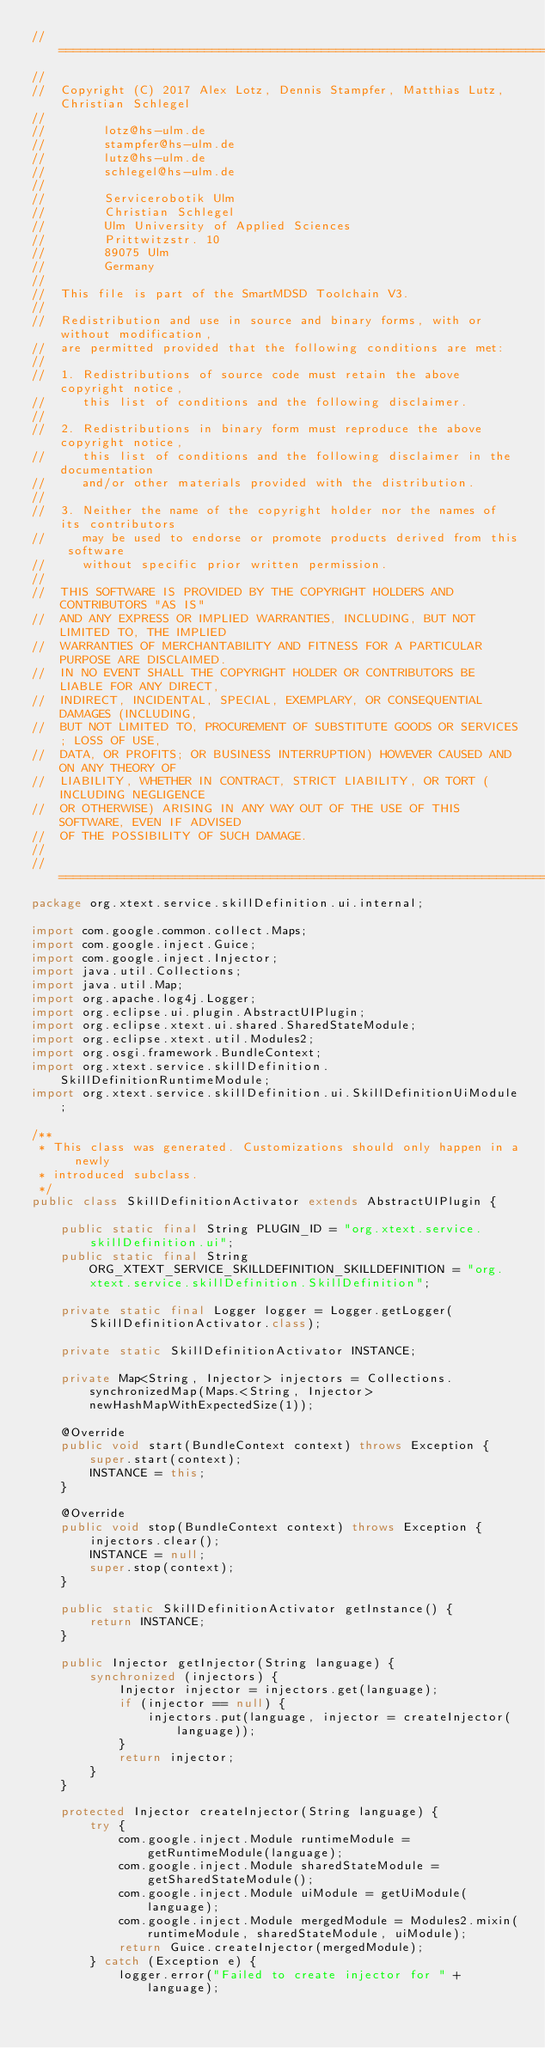<code> <loc_0><loc_0><loc_500><loc_500><_Java_>//===================================================================================
//
//  Copyright (C) 2017 Alex Lotz, Dennis Stampfer, Matthias Lutz, Christian Schlegel
//
//        lotz@hs-ulm.de
//        stampfer@hs-ulm.de
//        lutz@hs-ulm.de
//        schlegel@hs-ulm.de
//
//        Servicerobotik Ulm
//        Christian Schlegel
//        Ulm University of Applied Sciences
//        Prittwitzstr. 10
//        89075 Ulm
//        Germany
//
//  This file is part of the SmartMDSD Toolchain V3. 
//
//  Redistribution and use in source and binary forms, with or without modification, 
//  are permitted provided that the following conditions are met:
//  
//  1. Redistributions of source code must retain the above copyright notice, 
//     this list of conditions and the following disclaimer.
//  
//  2. Redistributions in binary form must reproduce the above copyright notice, 
//     this list of conditions and the following disclaimer in the documentation 
//     and/or other materials provided with the distribution.
//  
//  3. Neither the name of the copyright holder nor the names of its contributors 
//     may be used to endorse or promote products derived from this software 
//     without specific prior written permission.
//  
//  THIS SOFTWARE IS PROVIDED BY THE COPYRIGHT HOLDERS AND CONTRIBUTORS "AS IS" 
//  AND ANY EXPRESS OR IMPLIED WARRANTIES, INCLUDING, BUT NOT LIMITED TO, THE IMPLIED 
//  WARRANTIES OF MERCHANTABILITY AND FITNESS FOR A PARTICULAR PURPOSE ARE DISCLAIMED. 
//  IN NO EVENT SHALL THE COPYRIGHT HOLDER OR CONTRIBUTORS BE LIABLE FOR ANY DIRECT, 
//  INDIRECT, INCIDENTAL, SPECIAL, EXEMPLARY, OR CONSEQUENTIAL DAMAGES (INCLUDING, 
//  BUT NOT LIMITED TO, PROCUREMENT OF SUBSTITUTE GOODS OR SERVICES; LOSS OF USE, 
//  DATA, OR PROFITS; OR BUSINESS INTERRUPTION) HOWEVER CAUSED AND ON ANY THEORY OF 
//  LIABILITY, WHETHER IN CONTRACT, STRICT LIABILITY, OR TORT (INCLUDING NEGLIGENCE 
//  OR OTHERWISE) ARISING IN ANY WAY OUT OF THE USE OF THIS SOFTWARE, EVEN IF ADVISED 
//  OF THE POSSIBILITY OF SUCH DAMAGE.
//
//===================================================================================
package org.xtext.service.skillDefinition.ui.internal;

import com.google.common.collect.Maps;
import com.google.inject.Guice;
import com.google.inject.Injector;
import java.util.Collections;
import java.util.Map;
import org.apache.log4j.Logger;
import org.eclipse.ui.plugin.AbstractUIPlugin;
import org.eclipse.xtext.ui.shared.SharedStateModule;
import org.eclipse.xtext.util.Modules2;
import org.osgi.framework.BundleContext;
import org.xtext.service.skillDefinition.SkillDefinitionRuntimeModule;
import org.xtext.service.skillDefinition.ui.SkillDefinitionUiModule;

/**
 * This class was generated. Customizations should only happen in a newly
 * introduced subclass. 
 */
public class SkillDefinitionActivator extends AbstractUIPlugin {

	public static final String PLUGIN_ID = "org.xtext.service.skillDefinition.ui";
	public static final String ORG_XTEXT_SERVICE_SKILLDEFINITION_SKILLDEFINITION = "org.xtext.service.skillDefinition.SkillDefinition";
	
	private static final Logger logger = Logger.getLogger(SkillDefinitionActivator.class);
	
	private static SkillDefinitionActivator INSTANCE;
	
	private Map<String, Injector> injectors = Collections.synchronizedMap(Maps.<String, Injector> newHashMapWithExpectedSize(1));
	
	@Override
	public void start(BundleContext context) throws Exception {
		super.start(context);
		INSTANCE = this;
	}
	
	@Override
	public void stop(BundleContext context) throws Exception {
		injectors.clear();
		INSTANCE = null;
		super.stop(context);
	}
	
	public static SkillDefinitionActivator getInstance() {
		return INSTANCE;
	}
	
	public Injector getInjector(String language) {
		synchronized (injectors) {
			Injector injector = injectors.get(language);
			if (injector == null) {
				injectors.put(language, injector = createInjector(language));
			}
			return injector;
		}
	}
	
	protected Injector createInjector(String language) {
		try {
			com.google.inject.Module runtimeModule = getRuntimeModule(language);
			com.google.inject.Module sharedStateModule = getSharedStateModule();
			com.google.inject.Module uiModule = getUiModule(language);
			com.google.inject.Module mergedModule = Modules2.mixin(runtimeModule, sharedStateModule, uiModule);
			return Guice.createInjector(mergedModule);
		} catch (Exception e) {
			logger.error("Failed to create injector for " + language);</code> 